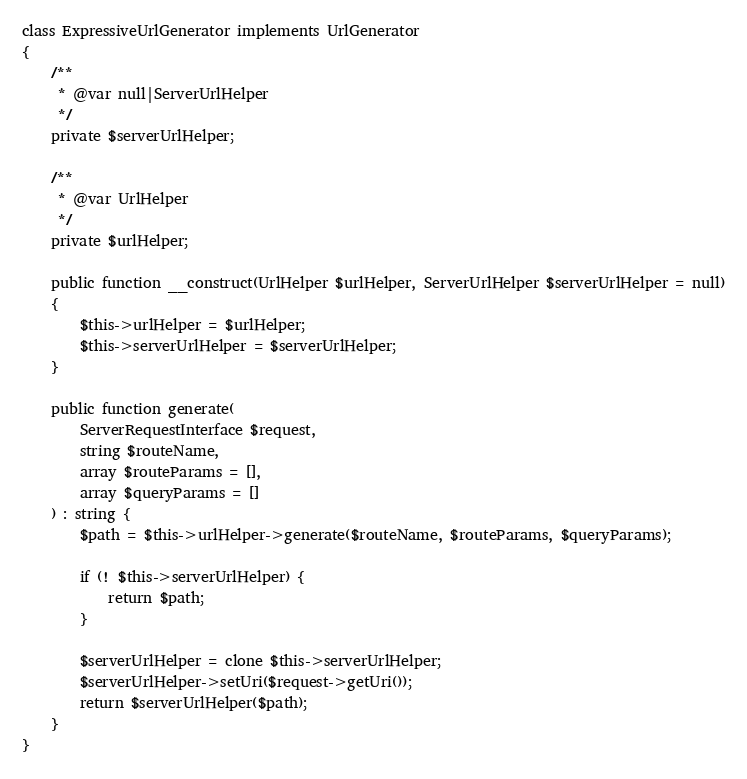Convert code to text. <code><loc_0><loc_0><loc_500><loc_500><_PHP_>
class ExpressiveUrlGenerator implements UrlGenerator
{
    /**
     * @var null|ServerUrlHelper
     */
    private $serverUrlHelper;

    /**
     * @var UrlHelper
     */
    private $urlHelper;

    public function __construct(UrlHelper $urlHelper, ServerUrlHelper $serverUrlHelper = null)
    {
        $this->urlHelper = $urlHelper;
        $this->serverUrlHelper = $serverUrlHelper;
    }

    public function generate(
        ServerRequestInterface $request,
        string $routeName,
        array $routeParams = [],
        array $queryParams = []
    ) : string {
        $path = $this->urlHelper->generate($routeName, $routeParams, $queryParams);

        if (! $this->serverUrlHelper) {
            return $path;
        }

        $serverUrlHelper = clone $this->serverUrlHelper;
        $serverUrlHelper->setUri($request->getUri());
        return $serverUrlHelper($path);
    }
}
</code> 